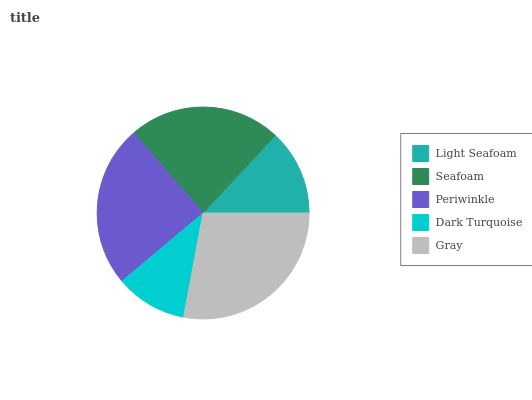Is Dark Turquoise the minimum?
Answer yes or no. Yes. Is Gray the maximum?
Answer yes or no. Yes. Is Seafoam the minimum?
Answer yes or no. No. Is Seafoam the maximum?
Answer yes or no. No. Is Seafoam greater than Light Seafoam?
Answer yes or no. Yes. Is Light Seafoam less than Seafoam?
Answer yes or no. Yes. Is Light Seafoam greater than Seafoam?
Answer yes or no. No. Is Seafoam less than Light Seafoam?
Answer yes or no. No. Is Seafoam the high median?
Answer yes or no. Yes. Is Seafoam the low median?
Answer yes or no. Yes. Is Light Seafoam the high median?
Answer yes or no. No. Is Gray the low median?
Answer yes or no. No. 